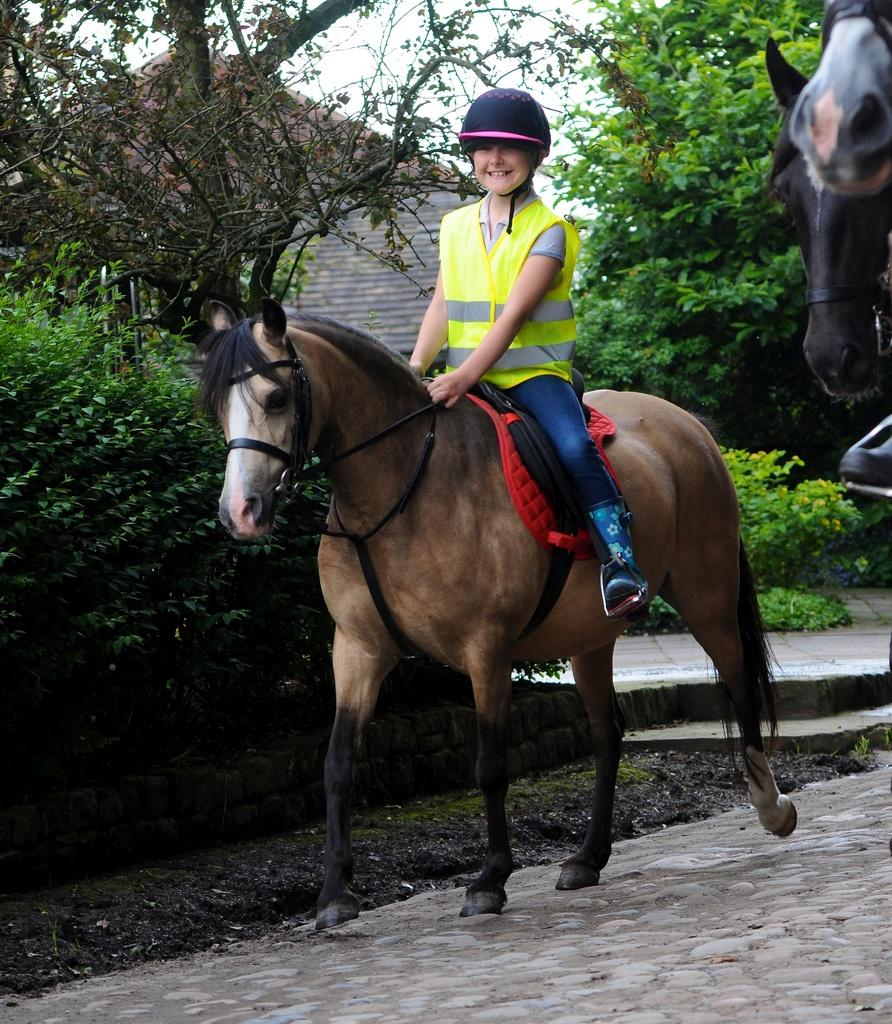Who is the main subject in the image? There is a boy in the image. What is the boy doing in the image? The boy is sitting on a horse. What can be seen in the background of the image? There are trees in the image. Are there any other horses in the image? Yes, there is another horse on the right side of the image. What type of fan is visible in the image? There is no fan present in the image. What is the boy using to ride the horse in the image? The boy is sitting on the horse, and there is no mention of a straw or any other object being used for riding. 